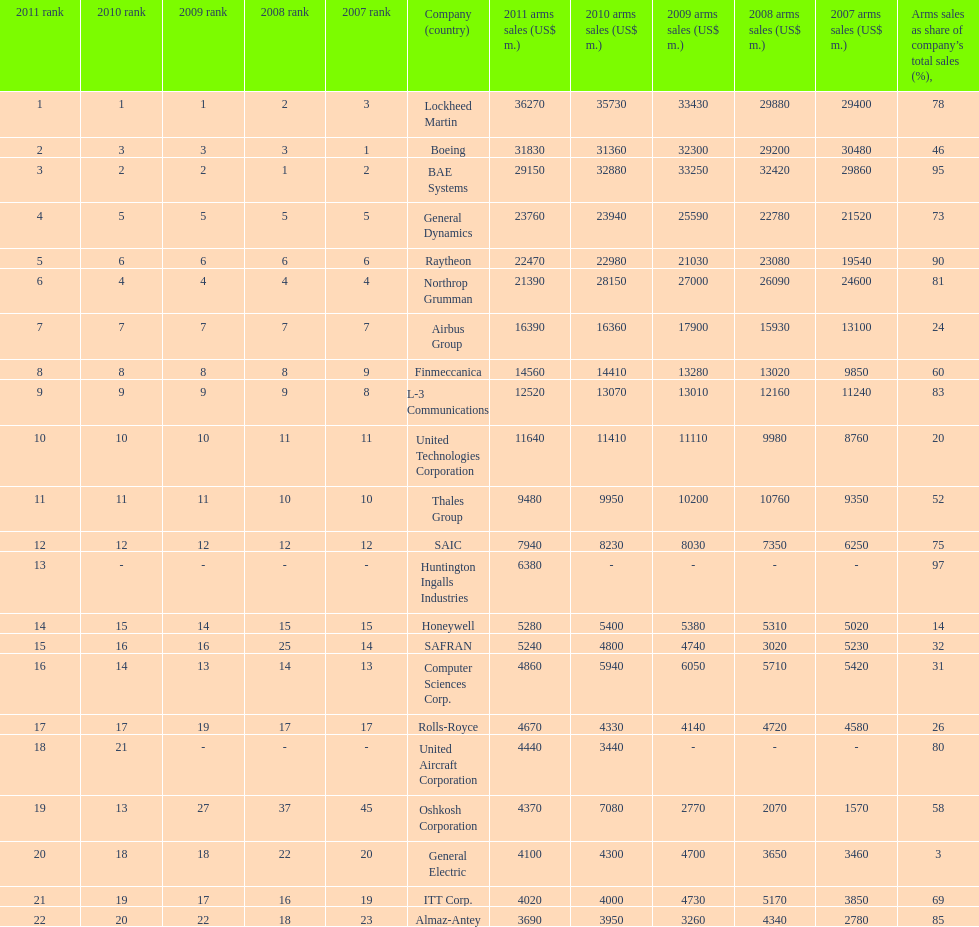In 2010, who recorded the smallest amount of sales? United Aircraft Corporation. 